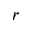<formula> <loc_0><loc_0><loc_500><loc_500>r</formula> 